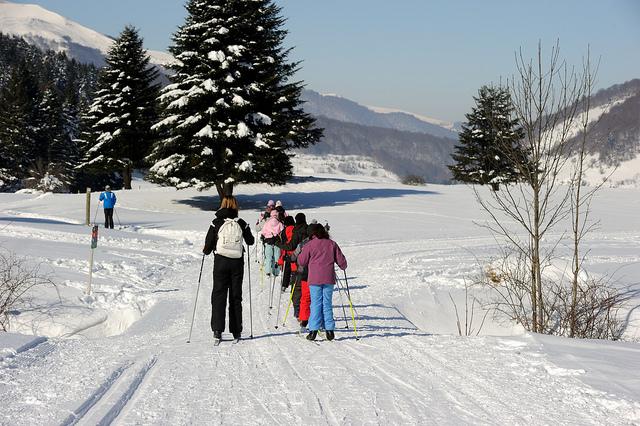What is the couple doing?
Short answer required. Skiing. Is anyone snowboarding?
Quick response, please. No. What are the people holding?
Be succinct. Ski poles. Does this look like a difficult slope to ski?
Short answer required. No. How many women are going to ski?
Short answer required. 9. How many people are seen?
Short answer required. 8. 